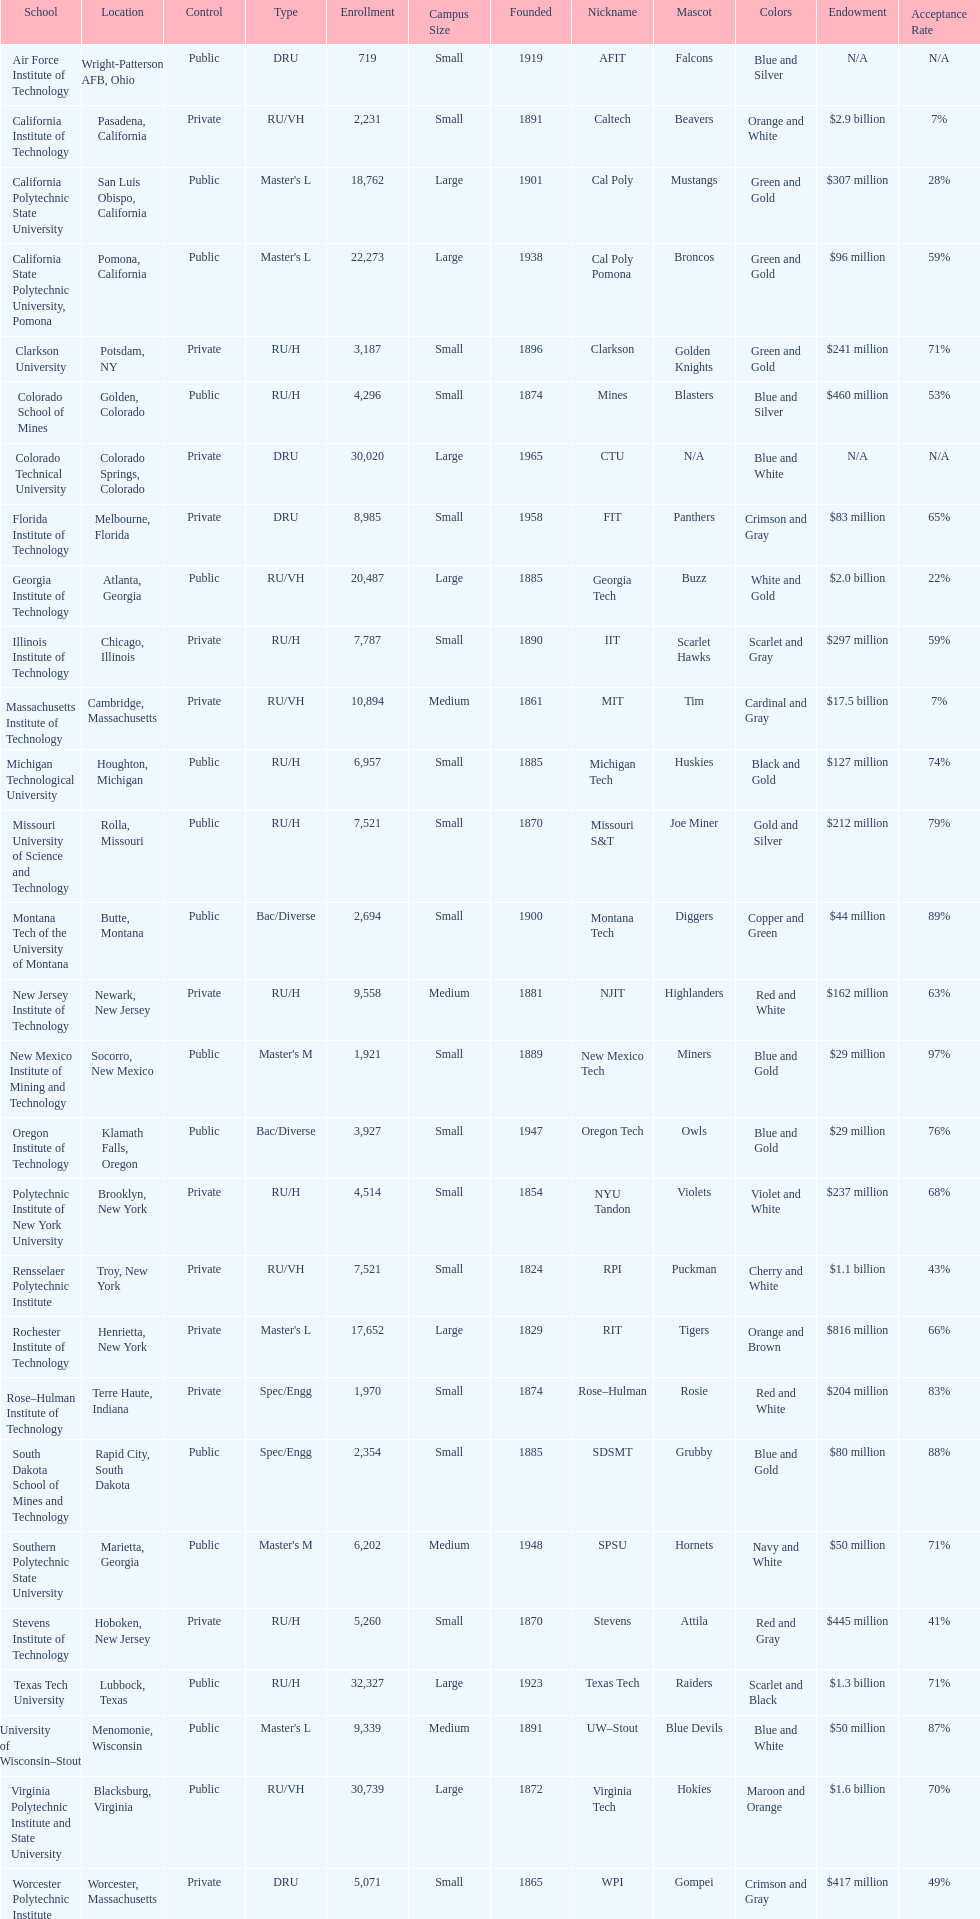What is the number of us technological schools in the state of california? 3. 